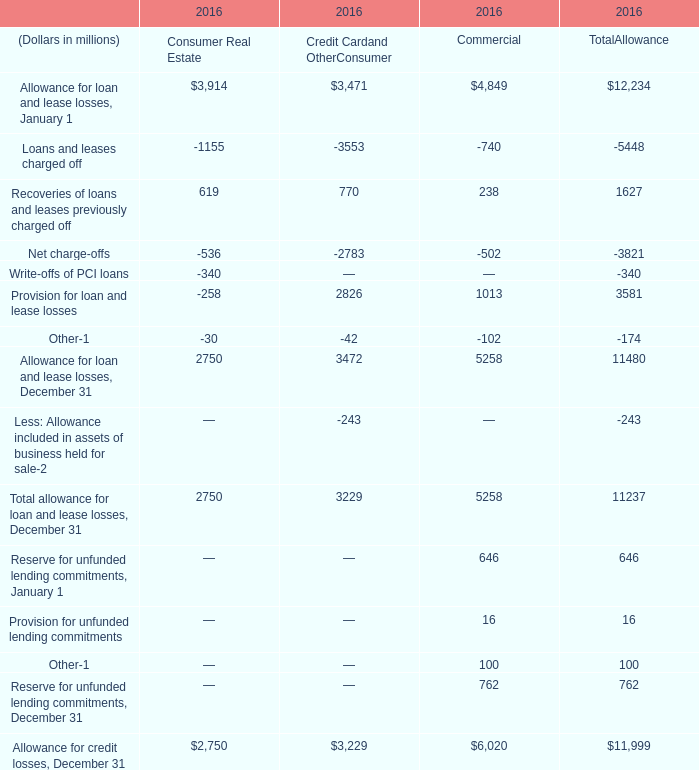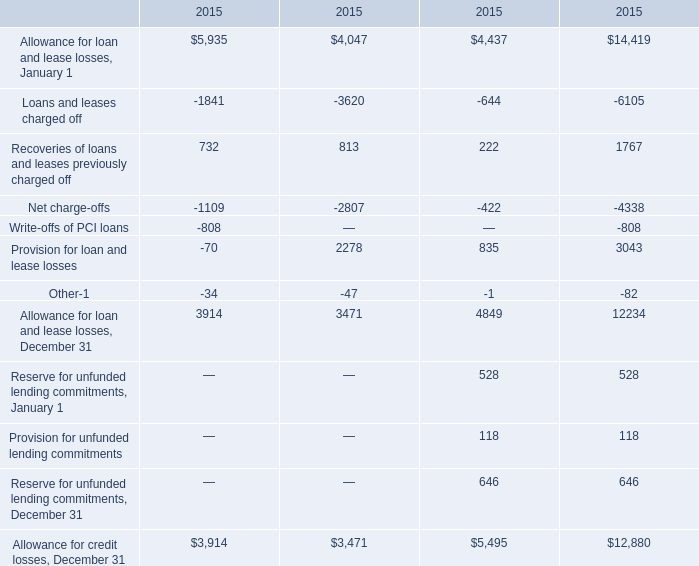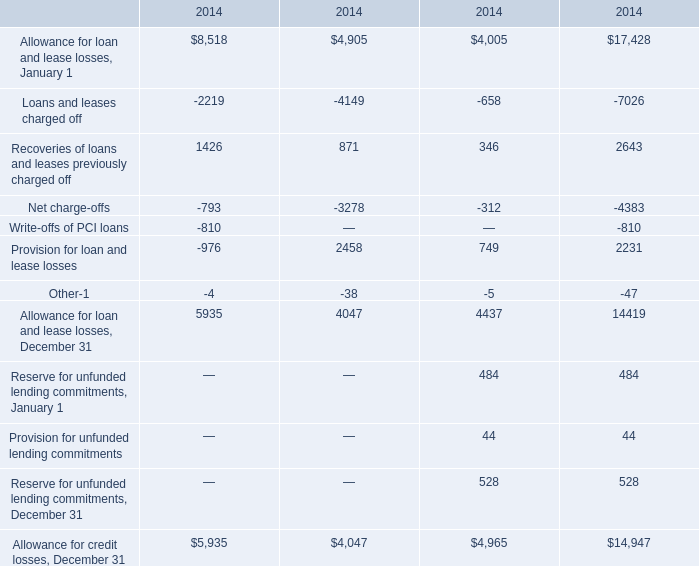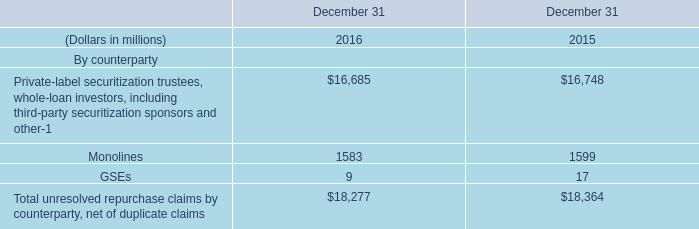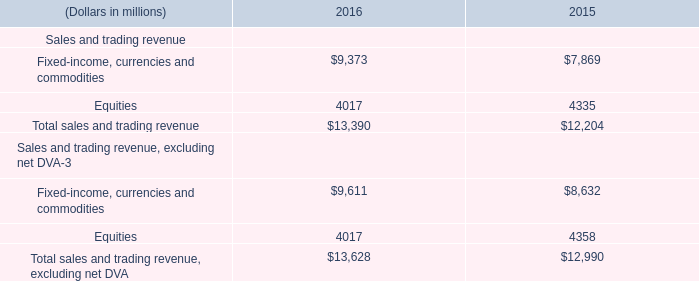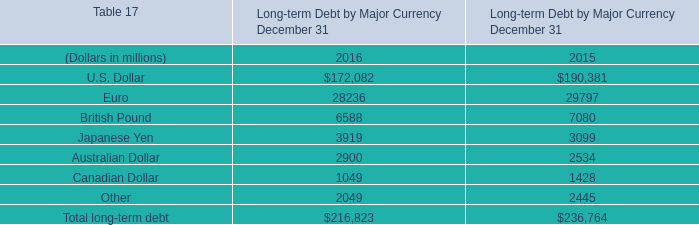What's the average of Allowance for credit losses, December 31 of 2015.3, and Provision for loan and lease losses of 2016 Commercial ? 
Computations: ((12880.0 + 1013.0) / 2)
Answer: 6946.5. 